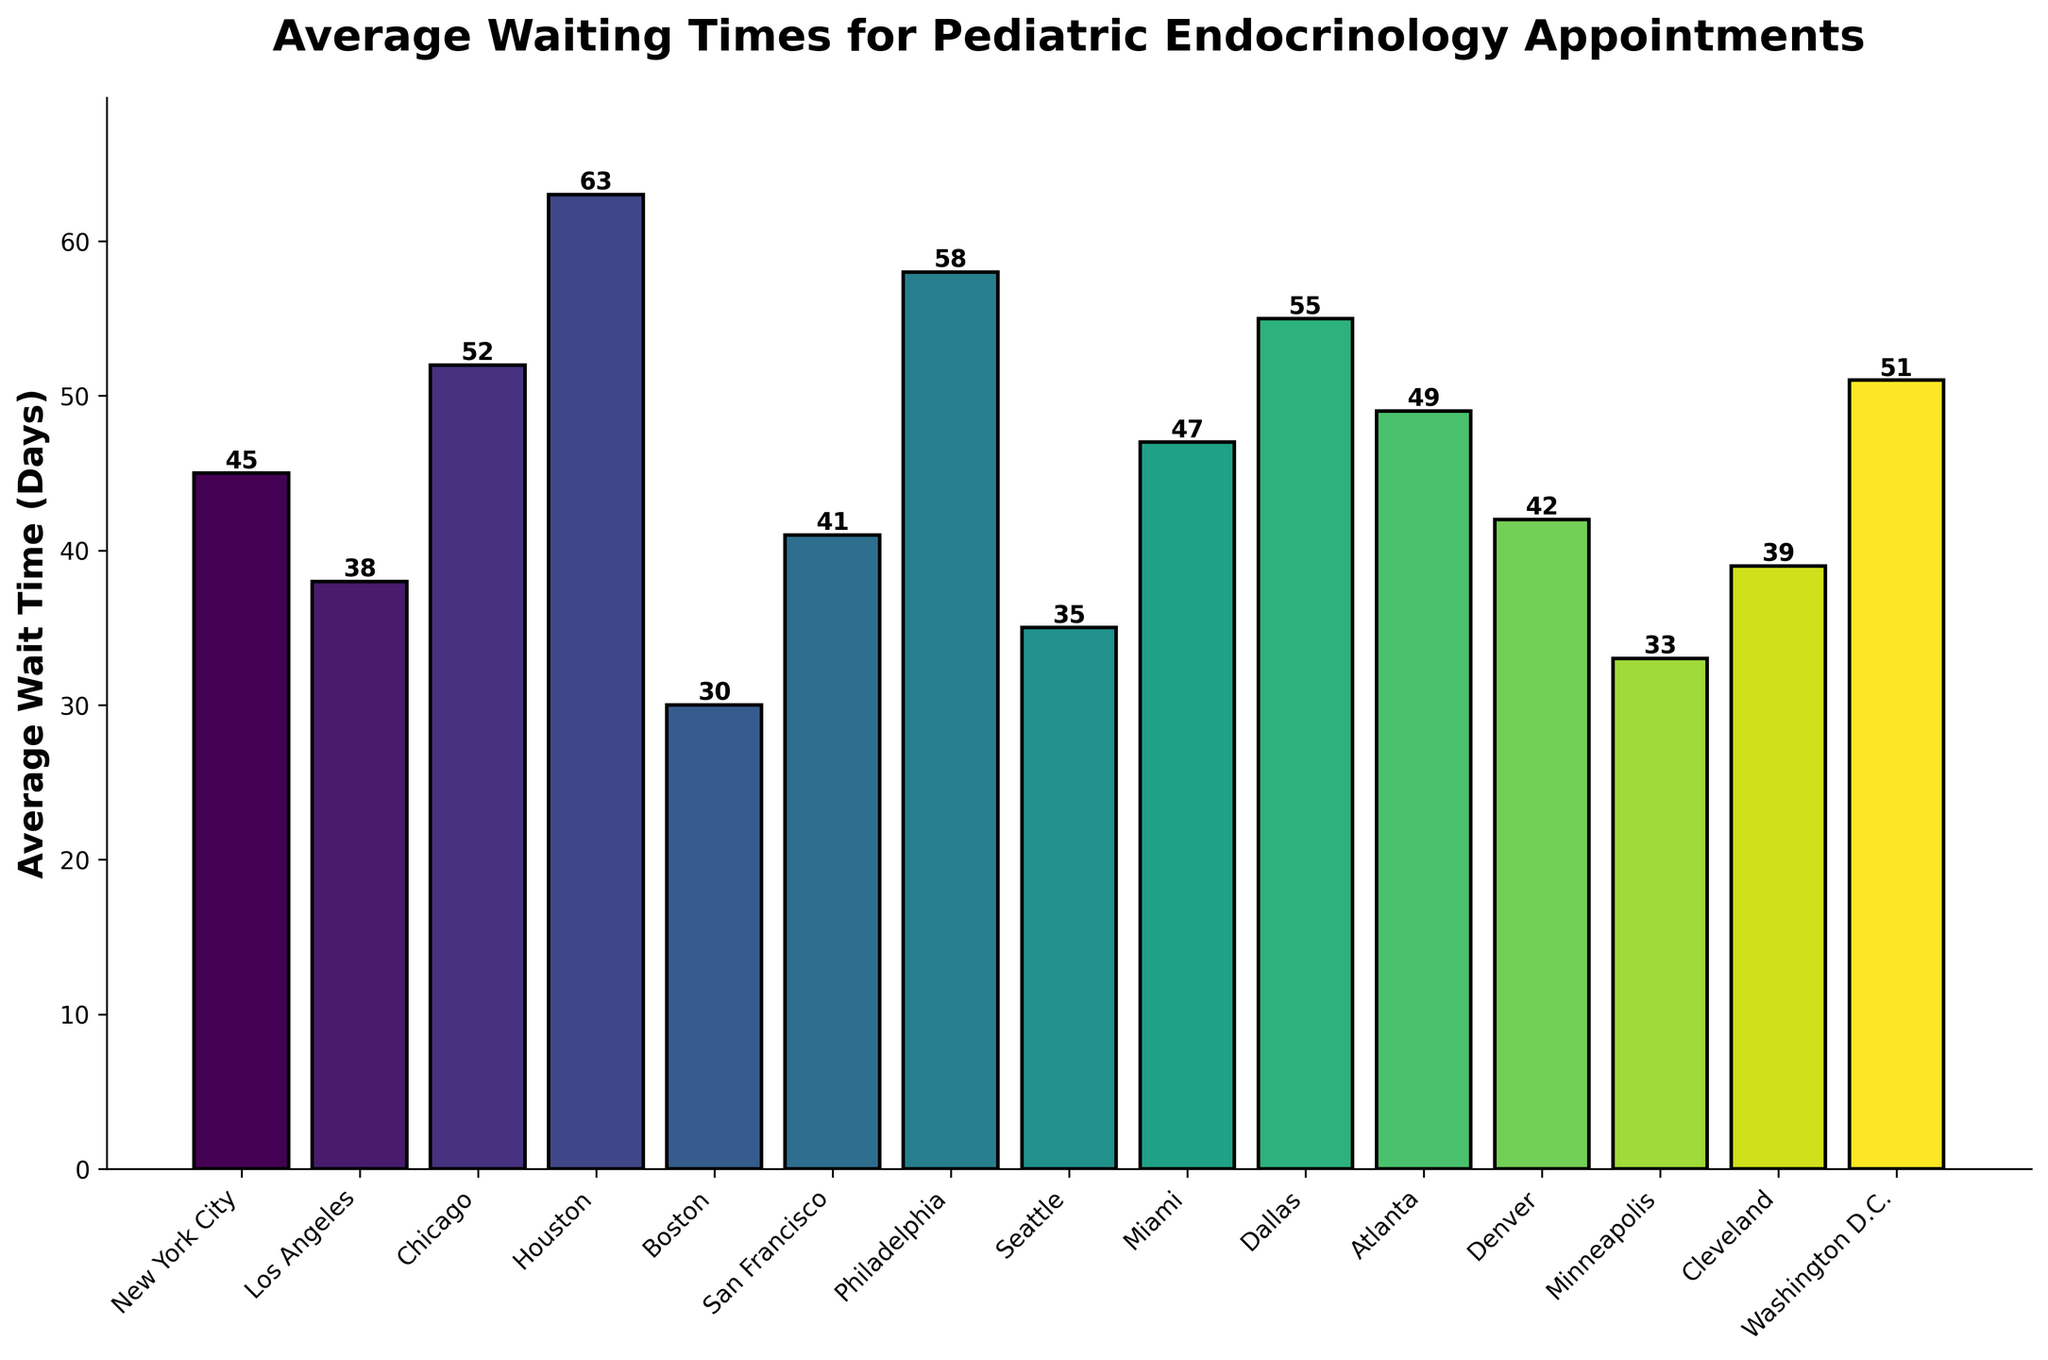What is the city with the shortest average waiting time for pediatric endocrinology appointments? The shortest waiting time is indicated by the shortest bar on the chart. From the chart, Boston has the shortest average waiting time.
Answer: Boston Which city has the longest average waiting time? The longest waiting time is indicated by the tallest bar on the chart. From the chart, Houston has the longest average waiting time.
Answer: Houston Compare the average waiting times between New York City and Seattle. Which one is shorter and by how many days? New York City has an average waiting time of 45 days, and Seattle has 35 days. The difference is calculated as 45 - 35 = 10 days, meaning Seattle's wait time is shorter by 10 days.
Answer: Seattle, 10 days What is the average waiting time for pediatric endocrinology appointments across all cities? The sum of the average waiting times for all the cities is (45 + 38 + 52 + 63 + 30 + 41 + 58 + 35 + 47 + 55 + 49 + 42 + 33 + 39 + 51) = 678 days. There are 15 cities in total, so the average is 678/15 = 45.2 days.
Answer: 45.2 days How many cities have an average waiting time longer than 50 days? From the chart, count the bars that are taller than 50 days. These cities are Chicago (52 days), Houston (63 days), Philadelphia (58 days), Dallas (55 days), and Washington D.C. (51 days), totaling five cities.
Answer: 5 cities Is the average waiting time in Miami greater than the average waiting time in Philadelphia? Miami's waiting time is 47 days, while Philadelphia's waiting time is 58 days. Comparing these two values, 47 is less than 58, so Miami's waiting time is not greater.
Answer: No Which cities have average waiting times that fall between 30 and 40 days inclusive? The bars that fall within this range are Boston (30 days), San Francisco (41 days), Cleveland (39 days), and Minneapolis (33 days). Summing these gives 4 cities.
Answer: Boston, San Francisco, Cleveland, Minneapolis If you combine the average waiting times of the three cities with the shortest waiting times, what is the total? The cities with the shortest waiting times are Boston (30 days), Minneapolis (33 days), and Seattle (35 days). The sum is 30 + 33 + 35 = 98 days.
Answer: 98 days What is the median average waiting time for pediatric endocrinology appointments across all cities? To find the median, list all average waiting times in ascending order and find the middle value. The sorted values are [30, 33, 35, 38, 39, 41, 42, 45, 47, 49, 51, 52, 55, 58, 63]. The middle value (8th in a list of 15) is 45 days.
Answer: 45 days 